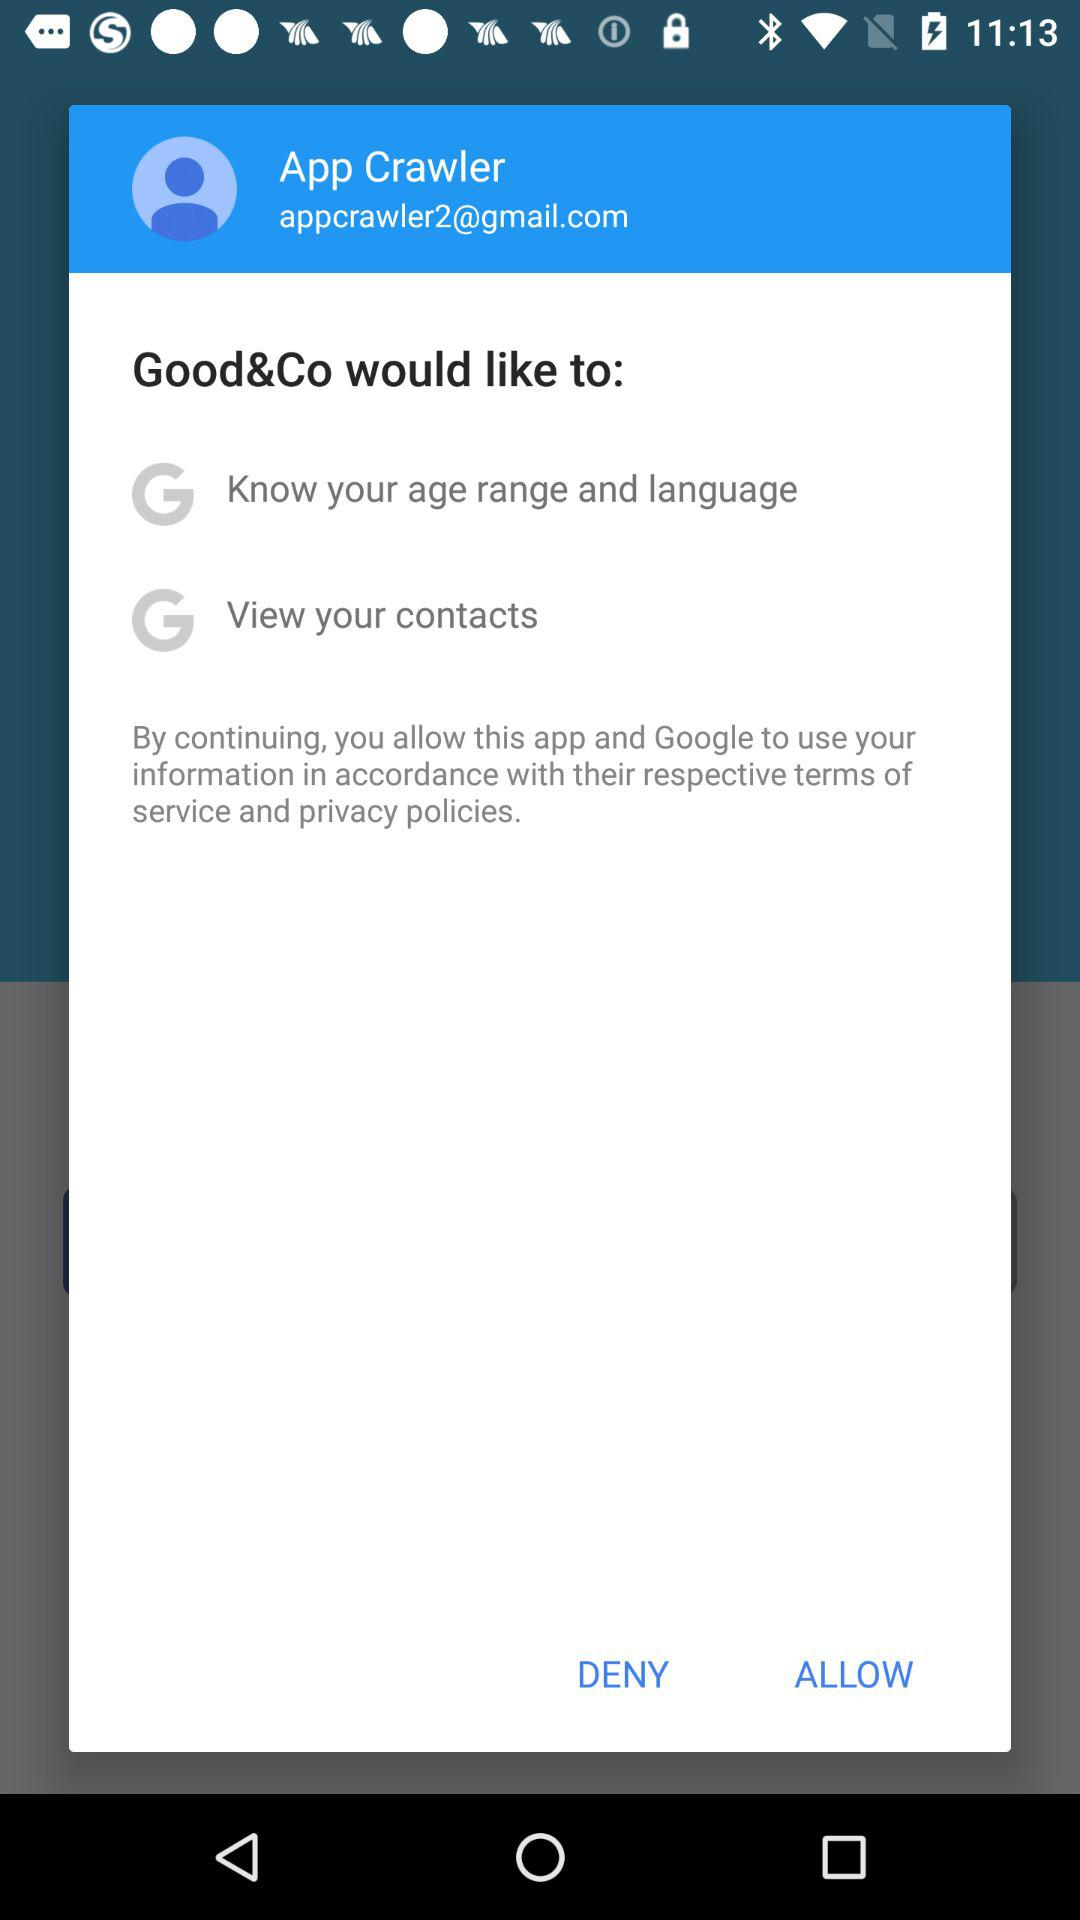What is the name of the user? The name of the user is App Crawler. 